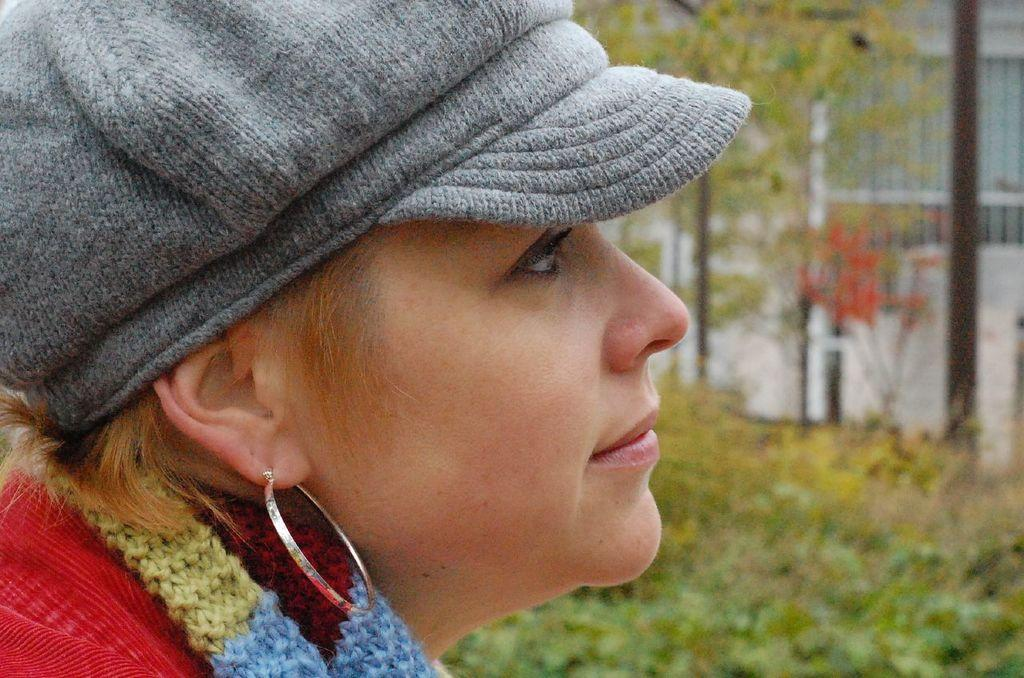What is the main subject of the image? There is a person in the image. Can you describe the person's clothing? The person is wearing an ash-colored cap and a colorful dress. What can be seen in the background of the image? There are trees visible in the image. How would you describe the background's appearance? The background of the image is blurred. What type of cherry is the person holding in the image? There is no cherry present in the image. Can you tell if the person is feeling any shame in the image? The image does not convey any emotions or feelings, so it is impossible to determine if the person is feeling shame. 